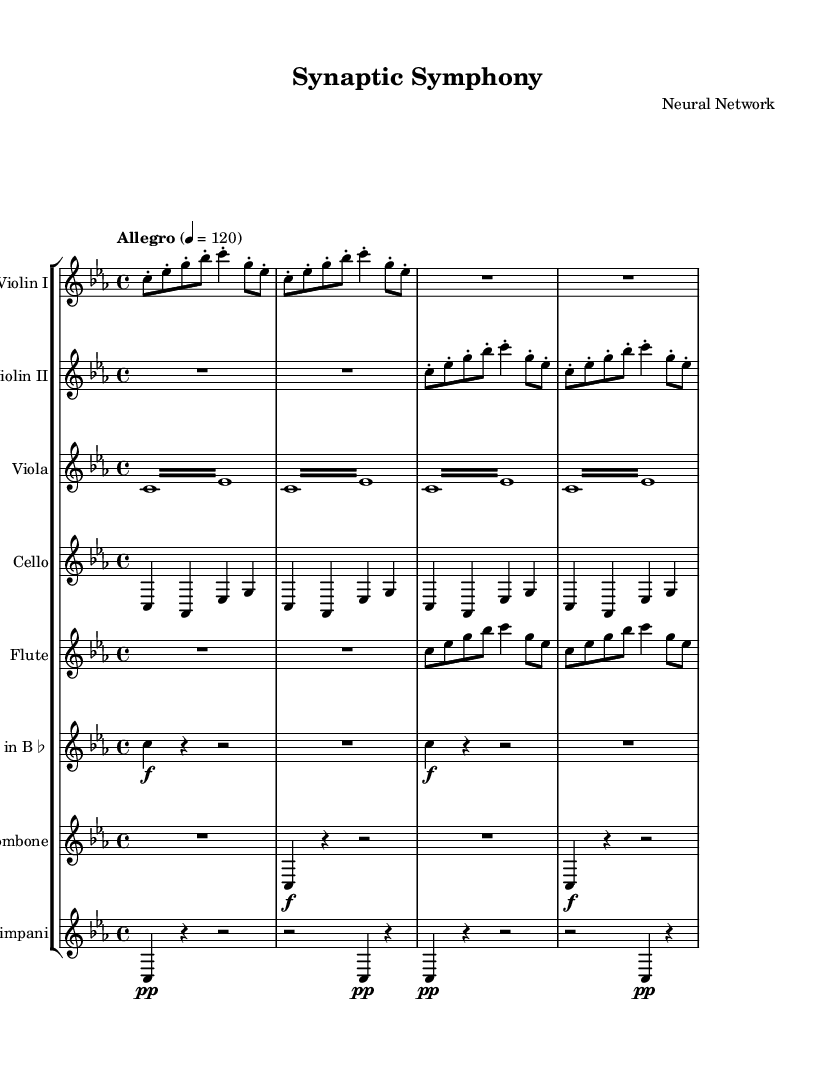What is the key signature of this music? The key signature is indicated at the beginning of the music, which shows no sharps or flats, indicating it is in C minor.
Answer: C minor What is the time signature of this piece? The time signature is displayed at the beginning of the music as 4/4, meaning there are four beats in each measure.
Answer: 4/4 What is the tempo marking of this composition? The tempo marking appears at the beginning and specifies "Allegro" with a metronome marking of 120 beats per minute, indicating a fast tempo.
Answer: Allegro, 120 What instruments are featured in the first part of the score? The score lists a staff group containing Violin I, Violin II, Viola, and Cello in the first part, indicating these instruments play at the beginning.
Answer: Violin I, Violin II, Viola, Cello How many measures are there in the Violin I part? By counting the measures in the Violin I part, there are a total of six measures present.
Answer: 6 What is significant about the rhythmic pattern in the viola part? The viola part features a repetitive tremolo, indicating a rapid alternation between two notes, which evokes the nature of neural impulses firing in succession.
Answer: Tremolo What dynamics are indicated for the trumpet and trombone parts? The trumpet and trombone parts both show initial dynamic markings of forte, indicating they should be played loudly.
Answer: Forte 